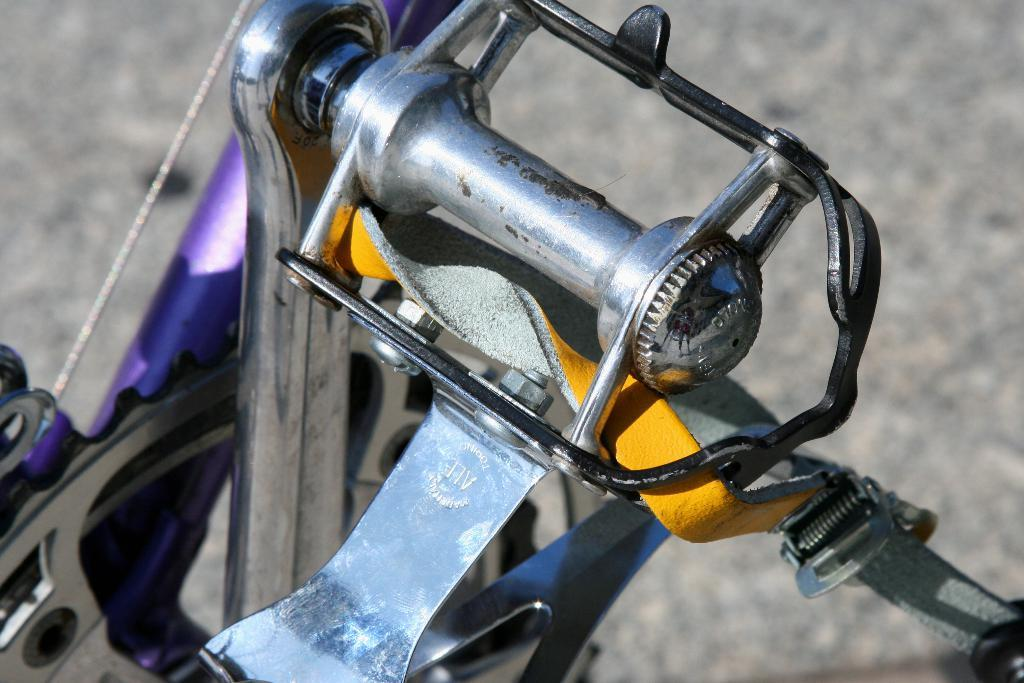What types of objects can be seen in the image? There are vehicles in the image. Can you describe any specific features of the vehicles? Yes, there are screws visible in the image, which may be part of the vehicles. Can you tell me how many pigs are visible in the image? There are no pigs present in the image. What type of ball can be seen in the image? There is no ball present in the image. 